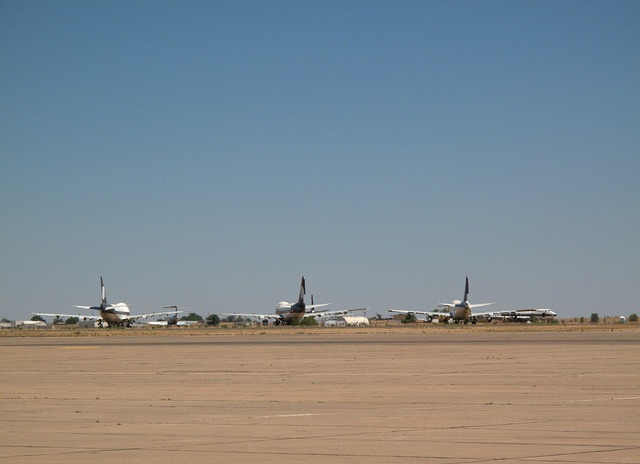Describe the objects in this image and their specific colors. I can see airplane in gray, darkgray, lightgray, and black tones, airplane in gray, black, darkgray, and lightgray tones, airplane in gray, darkgray, lightgray, and black tones, and airplane in gray, darkgray, black, and lightgray tones in this image. 